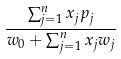Convert formula to latex. <formula><loc_0><loc_0><loc_500><loc_500>\frac { \sum _ { j = 1 } ^ { n } x _ { j } p _ { j } } { w _ { 0 } + \sum _ { j = 1 } ^ { n } x _ { j } w _ { j } }</formula> 